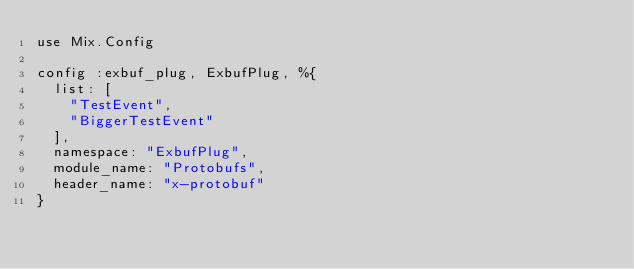Convert code to text. <code><loc_0><loc_0><loc_500><loc_500><_Elixir_>use Mix.Config

config :exbuf_plug, ExbufPlug, %{
  list: [
    "TestEvent",
    "BiggerTestEvent"
  ],
  namespace: "ExbufPlug",
  module_name: "Protobufs",
  header_name: "x-protobuf"
}
</code> 